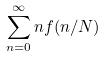<formula> <loc_0><loc_0><loc_500><loc_500>\sum _ { n = 0 } ^ { \infty } n f ( n / N )</formula> 